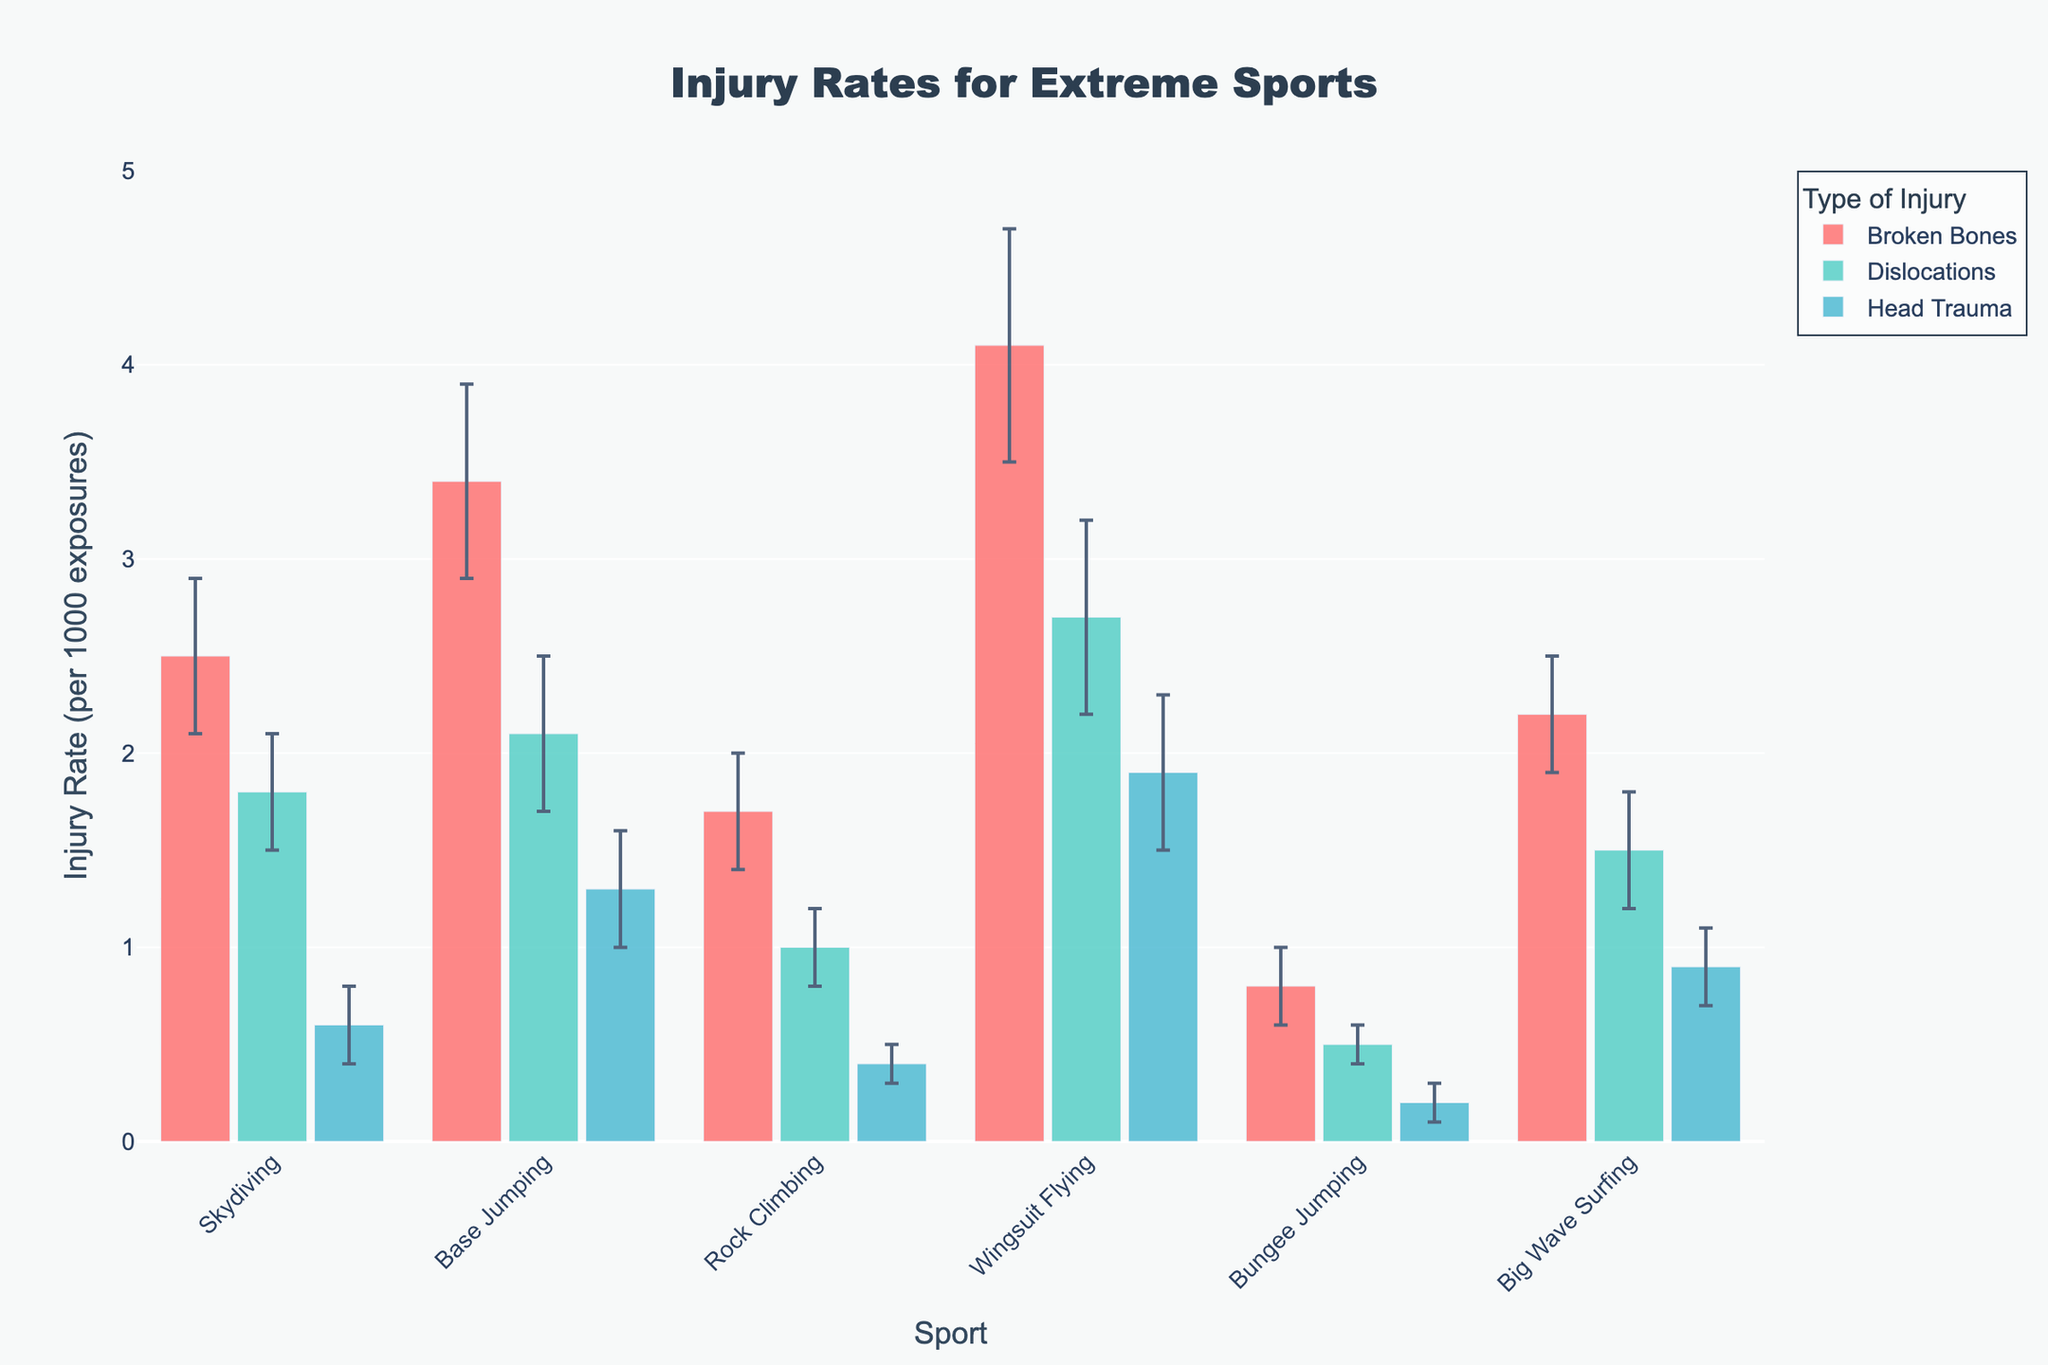How many types of injuries are represented in the figure? There are three distinct bars for each sport in different colors representing different types of injuries.
Answer: 3 Which sport has the highest injury rate for broken bones? By looking at the heights of the bars under "Broken Bones," Wingsuit Flying has the tallest bar for this category.
Answer: Wingsuit Flying What is the injury rate for head trauma in bungee jumping? The height of the bar representing "Head Trauma" in Bungee Jumping is 0.2 on the y-axis.
Answer: 0.2 Which type of injury has the highest average rate across all sports? Calculate the average injury rate by summing each type's rates and dividing by the number of sports. For Broken Bones: (2.5+3.4+1.7+4.1+0.8+2.2)/6 = 2.78. For Dislocations: (1.8+2.1+1.0+2.7+0.5+1.5)/6 = 1.6. For Head Trauma: (0.6+1.3+0.4+1.9+0.2+0.9)/6 = 0.88. Thus, Broken Bones have the highest average rate.
Answer: Broken Bones How does the injury rate for dislocations in skydiving compare to rock climbing? The bar for Dislocations in Skydiving is higher than in Rock Climbing, indicating a higher injury rate in Skydiving (1.8 vs. 1.0).
Answer: Higher in Skydiving Which sport has the smallest error margin for broken bones? The smallest error bar for "Broken Bones" appears in Rock Climbing, which visually has the shortest error bar.
Answer: Rock Climbing Is the injury rate for head trauma more variable in wingsuit flying or base jumping? Compare the length of the error bars for "Head Trauma" in Wingsuit Flying and Base Jumping. Wingsuit Flying has a larger error bar than Base Jumping (0.4 vs. 0.3).
Answer: Wingsuit Flying What is the total injury rate for dislocations in all types of sports combined? Sum the injury rates for "Dislocations" across all sports: 1.8 + 2.1 + 1.0 + 2.7 + 0.5 + 1.5 = 9.6.
Answer: 9.6 Which type of injury in skydiving has the highest rate? In Skydiving, the tallest bar among the three categories is for Broken Bones at 2.5.
Answer: Broken Bones 